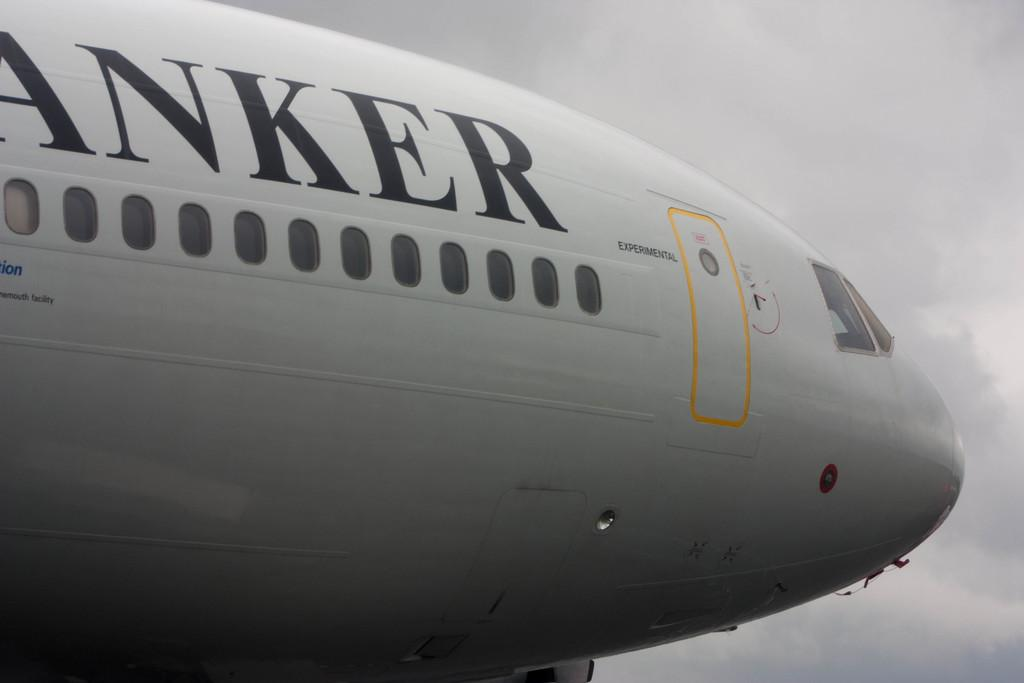What is the main subject of the picture? The main subject of the picture is an aeroplane. What color is the aeroplane? The aeroplane is white in color. Are there any markings or text on the aeroplane? Yes, there is text on the aeroplane. How would you describe the sky in the picture? The sky is cloudy in the picture. Can you see any visible veins on the aeroplane in the image? There are no visible veins on the aeroplane in the image, as veins are not a characteristic of aeroplanes. Is the grandmother sitting in the aeroplane in the image? There is no grandmother present in the image, as the focus is on the aeroplane itself. 